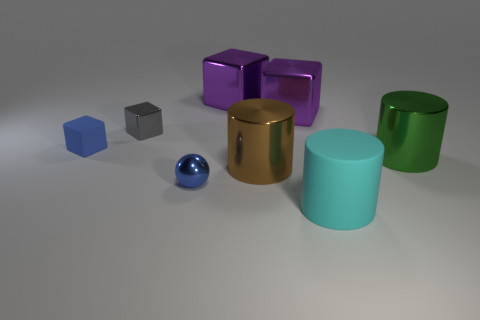What is the shape of the tiny matte object that is the same color as the metallic ball?
Keep it short and to the point. Cube. Is the size of the green shiny cylinder the same as the matte object that is in front of the big brown metal cylinder?
Your answer should be very brief. Yes. What color is the small shiny thing that is behind the small metal thing in front of the blue matte cube that is left of the big cyan object?
Your answer should be very brief. Gray. What color is the matte cube?
Keep it short and to the point. Blue. Are there more metal cylinders behind the small matte object than big brown shiny cylinders that are left of the small blue metallic sphere?
Keep it short and to the point. No. Do the tiny blue rubber thing and the rubber thing right of the blue cube have the same shape?
Provide a short and direct response. No. There is a gray shiny cube that is behind the tiny rubber block; is it the same size as the block right of the large brown cylinder?
Offer a very short reply. No. There is a cylinder that is in front of the big cylinder on the left side of the big cyan matte cylinder; are there any brown things in front of it?
Make the answer very short. No. Is the number of cyan cylinders to the left of the small blue rubber block less than the number of tiny metal spheres behind the tiny blue metallic ball?
Keep it short and to the point. No. The gray thing that is the same material as the brown cylinder is what shape?
Your response must be concise. Cube. 